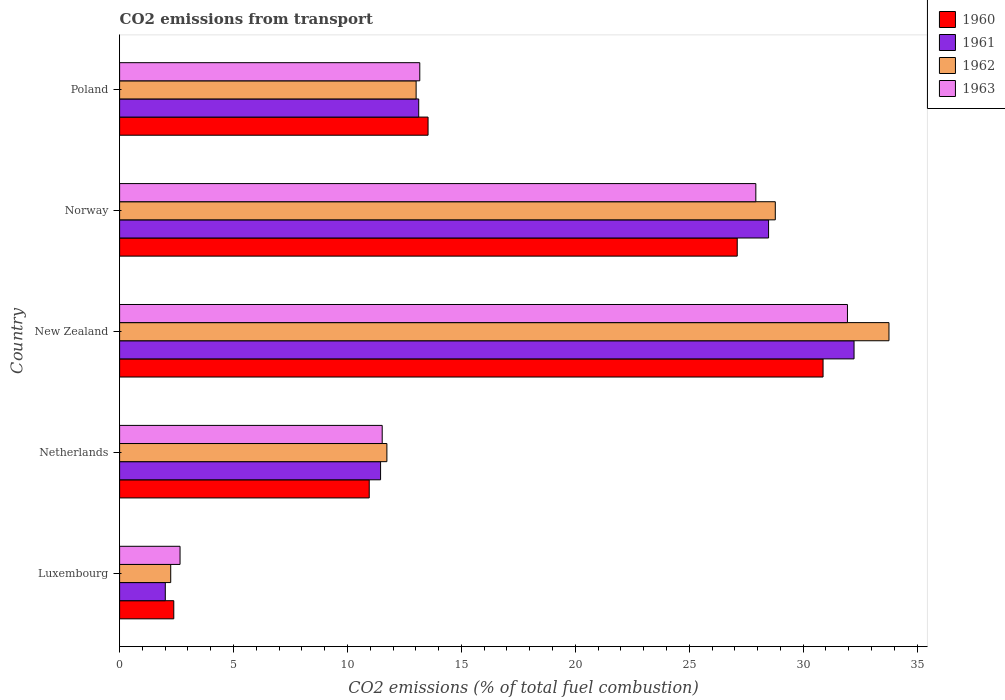How many different coloured bars are there?
Keep it short and to the point. 4. Are the number of bars on each tick of the Y-axis equal?
Your answer should be compact. Yes. What is the total CO2 emitted in 1963 in Luxembourg?
Your response must be concise. 2.65. Across all countries, what is the maximum total CO2 emitted in 1963?
Provide a succinct answer. 31.94. Across all countries, what is the minimum total CO2 emitted in 1960?
Your answer should be compact. 2.38. In which country was the total CO2 emitted in 1960 maximum?
Give a very brief answer. New Zealand. In which country was the total CO2 emitted in 1961 minimum?
Offer a terse response. Luxembourg. What is the total total CO2 emitted in 1963 in the graph?
Keep it short and to the point. 87.22. What is the difference between the total CO2 emitted in 1963 in Luxembourg and that in Norway?
Provide a succinct answer. -25.27. What is the difference between the total CO2 emitted in 1961 in Netherlands and the total CO2 emitted in 1963 in New Zealand?
Give a very brief answer. -20.49. What is the average total CO2 emitted in 1961 per country?
Keep it short and to the point. 17.46. What is the difference between the total CO2 emitted in 1960 and total CO2 emitted in 1963 in New Zealand?
Your answer should be compact. -1.07. In how many countries, is the total CO2 emitted in 1960 greater than 11 ?
Your answer should be compact. 3. What is the ratio of the total CO2 emitted in 1962 in Luxembourg to that in Norway?
Keep it short and to the point. 0.08. Is the difference between the total CO2 emitted in 1960 in New Zealand and Poland greater than the difference between the total CO2 emitted in 1963 in New Zealand and Poland?
Give a very brief answer. No. What is the difference between the highest and the second highest total CO2 emitted in 1962?
Ensure brevity in your answer.  4.99. What is the difference between the highest and the lowest total CO2 emitted in 1963?
Make the answer very short. 29.29. Is it the case that in every country, the sum of the total CO2 emitted in 1960 and total CO2 emitted in 1962 is greater than the sum of total CO2 emitted in 1961 and total CO2 emitted in 1963?
Your response must be concise. No. What is the difference between two consecutive major ticks on the X-axis?
Give a very brief answer. 5. Are the values on the major ticks of X-axis written in scientific E-notation?
Your answer should be very brief. No. Does the graph contain any zero values?
Your answer should be compact. No. Does the graph contain grids?
Provide a short and direct response. No. How many legend labels are there?
Your answer should be very brief. 4. What is the title of the graph?
Offer a terse response. CO2 emissions from transport. Does "1999" appear as one of the legend labels in the graph?
Make the answer very short. No. What is the label or title of the X-axis?
Provide a succinct answer. CO2 emissions (% of total fuel combustion). What is the label or title of the Y-axis?
Provide a short and direct response. Country. What is the CO2 emissions (% of total fuel combustion) in 1960 in Luxembourg?
Offer a very short reply. 2.38. What is the CO2 emissions (% of total fuel combustion) in 1961 in Luxembourg?
Give a very brief answer. 2.01. What is the CO2 emissions (% of total fuel combustion) of 1962 in Luxembourg?
Provide a short and direct response. 2.24. What is the CO2 emissions (% of total fuel combustion) in 1963 in Luxembourg?
Your answer should be compact. 2.65. What is the CO2 emissions (% of total fuel combustion) of 1960 in Netherlands?
Provide a short and direct response. 10.96. What is the CO2 emissions (% of total fuel combustion) of 1961 in Netherlands?
Your answer should be very brief. 11.45. What is the CO2 emissions (% of total fuel combustion) of 1962 in Netherlands?
Your response must be concise. 11.73. What is the CO2 emissions (% of total fuel combustion) in 1963 in Netherlands?
Give a very brief answer. 11.53. What is the CO2 emissions (% of total fuel combustion) of 1960 in New Zealand?
Your answer should be very brief. 30.87. What is the CO2 emissions (% of total fuel combustion) in 1961 in New Zealand?
Your answer should be compact. 32.23. What is the CO2 emissions (% of total fuel combustion) of 1962 in New Zealand?
Keep it short and to the point. 33.77. What is the CO2 emissions (% of total fuel combustion) in 1963 in New Zealand?
Provide a succinct answer. 31.94. What is the CO2 emissions (% of total fuel combustion) of 1960 in Norway?
Your answer should be compact. 27.11. What is the CO2 emissions (% of total fuel combustion) in 1961 in Norway?
Your response must be concise. 28.48. What is the CO2 emissions (% of total fuel combustion) in 1962 in Norway?
Provide a succinct answer. 28.78. What is the CO2 emissions (% of total fuel combustion) in 1963 in Norway?
Your answer should be compact. 27.92. What is the CO2 emissions (% of total fuel combustion) of 1960 in Poland?
Offer a terse response. 13.54. What is the CO2 emissions (% of total fuel combustion) in 1961 in Poland?
Give a very brief answer. 13.13. What is the CO2 emissions (% of total fuel combustion) of 1962 in Poland?
Provide a succinct answer. 13.01. What is the CO2 emissions (% of total fuel combustion) of 1963 in Poland?
Ensure brevity in your answer.  13.17. Across all countries, what is the maximum CO2 emissions (% of total fuel combustion) of 1960?
Make the answer very short. 30.87. Across all countries, what is the maximum CO2 emissions (% of total fuel combustion) of 1961?
Offer a very short reply. 32.23. Across all countries, what is the maximum CO2 emissions (% of total fuel combustion) in 1962?
Keep it short and to the point. 33.77. Across all countries, what is the maximum CO2 emissions (% of total fuel combustion) of 1963?
Make the answer very short. 31.94. Across all countries, what is the minimum CO2 emissions (% of total fuel combustion) of 1960?
Provide a short and direct response. 2.38. Across all countries, what is the minimum CO2 emissions (% of total fuel combustion) of 1961?
Your answer should be compact. 2.01. Across all countries, what is the minimum CO2 emissions (% of total fuel combustion) of 1962?
Provide a short and direct response. 2.24. Across all countries, what is the minimum CO2 emissions (% of total fuel combustion) in 1963?
Offer a terse response. 2.65. What is the total CO2 emissions (% of total fuel combustion) of 1960 in the graph?
Your response must be concise. 84.85. What is the total CO2 emissions (% of total fuel combustion) of 1961 in the graph?
Provide a short and direct response. 87.3. What is the total CO2 emissions (% of total fuel combustion) in 1962 in the graph?
Ensure brevity in your answer.  89.53. What is the total CO2 emissions (% of total fuel combustion) in 1963 in the graph?
Provide a succinct answer. 87.22. What is the difference between the CO2 emissions (% of total fuel combustion) in 1960 in Luxembourg and that in Netherlands?
Make the answer very short. -8.58. What is the difference between the CO2 emissions (% of total fuel combustion) of 1961 in Luxembourg and that in Netherlands?
Your answer should be very brief. -9.45. What is the difference between the CO2 emissions (% of total fuel combustion) of 1962 in Luxembourg and that in Netherlands?
Keep it short and to the point. -9.49. What is the difference between the CO2 emissions (% of total fuel combustion) of 1963 in Luxembourg and that in Netherlands?
Your answer should be compact. -8.87. What is the difference between the CO2 emissions (% of total fuel combustion) in 1960 in Luxembourg and that in New Zealand?
Ensure brevity in your answer.  -28.5. What is the difference between the CO2 emissions (% of total fuel combustion) of 1961 in Luxembourg and that in New Zealand?
Give a very brief answer. -30.23. What is the difference between the CO2 emissions (% of total fuel combustion) in 1962 in Luxembourg and that in New Zealand?
Your response must be concise. -31.52. What is the difference between the CO2 emissions (% of total fuel combustion) of 1963 in Luxembourg and that in New Zealand?
Give a very brief answer. -29.29. What is the difference between the CO2 emissions (% of total fuel combustion) of 1960 in Luxembourg and that in Norway?
Provide a short and direct response. -24.73. What is the difference between the CO2 emissions (% of total fuel combustion) of 1961 in Luxembourg and that in Norway?
Make the answer very short. -26.48. What is the difference between the CO2 emissions (% of total fuel combustion) in 1962 in Luxembourg and that in Norway?
Your answer should be very brief. -26.53. What is the difference between the CO2 emissions (% of total fuel combustion) in 1963 in Luxembourg and that in Norway?
Your response must be concise. -25.27. What is the difference between the CO2 emissions (% of total fuel combustion) of 1960 in Luxembourg and that in Poland?
Make the answer very short. -11.16. What is the difference between the CO2 emissions (% of total fuel combustion) of 1961 in Luxembourg and that in Poland?
Offer a very short reply. -11.12. What is the difference between the CO2 emissions (% of total fuel combustion) of 1962 in Luxembourg and that in Poland?
Your answer should be very brief. -10.77. What is the difference between the CO2 emissions (% of total fuel combustion) of 1963 in Luxembourg and that in Poland?
Your answer should be very brief. -10.52. What is the difference between the CO2 emissions (% of total fuel combustion) of 1960 in Netherlands and that in New Zealand?
Provide a succinct answer. -19.92. What is the difference between the CO2 emissions (% of total fuel combustion) of 1961 in Netherlands and that in New Zealand?
Your answer should be compact. -20.78. What is the difference between the CO2 emissions (% of total fuel combustion) of 1962 in Netherlands and that in New Zealand?
Provide a succinct answer. -22.04. What is the difference between the CO2 emissions (% of total fuel combustion) of 1963 in Netherlands and that in New Zealand?
Keep it short and to the point. -20.42. What is the difference between the CO2 emissions (% of total fuel combustion) in 1960 in Netherlands and that in Norway?
Provide a short and direct response. -16.15. What is the difference between the CO2 emissions (% of total fuel combustion) in 1961 in Netherlands and that in Norway?
Keep it short and to the point. -17.03. What is the difference between the CO2 emissions (% of total fuel combustion) in 1962 in Netherlands and that in Norway?
Your answer should be compact. -17.05. What is the difference between the CO2 emissions (% of total fuel combustion) in 1963 in Netherlands and that in Norway?
Keep it short and to the point. -16.4. What is the difference between the CO2 emissions (% of total fuel combustion) in 1960 in Netherlands and that in Poland?
Provide a succinct answer. -2.58. What is the difference between the CO2 emissions (% of total fuel combustion) in 1961 in Netherlands and that in Poland?
Keep it short and to the point. -1.67. What is the difference between the CO2 emissions (% of total fuel combustion) in 1962 in Netherlands and that in Poland?
Give a very brief answer. -1.28. What is the difference between the CO2 emissions (% of total fuel combustion) of 1963 in Netherlands and that in Poland?
Give a very brief answer. -1.65. What is the difference between the CO2 emissions (% of total fuel combustion) in 1960 in New Zealand and that in Norway?
Make the answer very short. 3.77. What is the difference between the CO2 emissions (% of total fuel combustion) in 1961 in New Zealand and that in Norway?
Keep it short and to the point. 3.75. What is the difference between the CO2 emissions (% of total fuel combustion) of 1962 in New Zealand and that in Norway?
Keep it short and to the point. 4.99. What is the difference between the CO2 emissions (% of total fuel combustion) in 1963 in New Zealand and that in Norway?
Offer a very short reply. 4.02. What is the difference between the CO2 emissions (% of total fuel combustion) in 1960 in New Zealand and that in Poland?
Provide a short and direct response. 17.34. What is the difference between the CO2 emissions (% of total fuel combustion) in 1961 in New Zealand and that in Poland?
Provide a short and direct response. 19.11. What is the difference between the CO2 emissions (% of total fuel combustion) of 1962 in New Zealand and that in Poland?
Your answer should be compact. 20.75. What is the difference between the CO2 emissions (% of total fuel combustion) of 1963 in New Zealand and that in Poland?
Offer a very short reply. 18.77. What is the difference between the CO2 emissions (% of total fuel combustion) of 1960 in Norway and that in Poland?
Ensure brevity in your answer.  13.57. What is the difference between the CO2 emissions (% of total fuel combustion) in 1961 in Norway and that in Poland?
Offer a terse response. 15.36. What is the difference between the CO2 emissions (% of total fuel combustion) in 1962 in Norway and that in Poland?
Offer a terse response. 15.76. What is the difference between the CO2 emissions (% of total fuel combustion) in 1963 in Norway and that in Poland?
Provide a succinct answer. 14.75. What is the difference between the CO2 emissions (% of total fuel combustion) in 1960 in Luxembourg and the CO2 emissions (% of total fuel combustion) in 1961 in Netherlands?
Offer a terse response. -9.08. What is the difference between the CO2 emissions (% of total fuel combustion) in 1960 in Luxembourg and the CO2 emissions (% of total fuel combustion) in 1962 in Netherlands?
Give a very brief answer. -9.35. What is the difference between the CO2 emissions (% of total fuel combustion) in 1960 in Luxembourg and the CO2 emissions (% of total fuel combustion) in 1963 in Netherlands?
Provide a succinct answer. -9.15. What is the difference between the CO2 emissions (% of total fuel combustion) of 1961 in Luxembourg and the CO2 emissions (% of total fuel combustion) of 1962 in Netherlands?
Ensure brevity in your answer.  -9.72. What is the difference between the CO2 emissions (% of total fuel combustion) of 1961 in Luxembourg and the CO2 emissions (% of total fuel combustion) of 1963 in Netherlands?
Your answer should be very brief. -9.52. What is the difference between the CO2 emissions (% of total fuel combustion) of 1962 in Luxembourg and the CO2 emissions (% of total fuel combustion) of 1963 in Netherlands?
Provide a short and direct response. -9.28. What is the difference between the CO2 emissions (% of total fuel combustion) in 1960 in Luxembourg and the CO2 emissions (% of total fuel combustion) in 1961 in New Zealand?
Offer a terse response. -29.86. What is the difference between the CO2 emissions (% of total fuel combustion) of 1960 in Luxembourg and the CO2 emissions (% of total fuel combustion) of 1962 in New Zealand?
Provide a succinct answer. -31.39. What is the difference between the CO2 emissions (% of total fuel combustion) of 1960 in Luxembourg and the CO2 emissions (% of total fuel combustion) of 1963 in New Zealand?
Make the answer very short. -29.57. What is the difference between the CO2 emissions (% of total fuel combustion) of 1961 in Luxembourg and the CO2 emissions (% of total fuel combustion) of 1962 in New Zealand?
Offer a terse response. -31.76. What is the difference between the CO2 emissions (% of total fuel combustion) in 1961 in Luxembourg and the CO2 emissions (% of total fuel combustion) in 1963 in New Zealand?
Your answer should be compact. -29.94. What is the difference between the CO2 emissions (% of total fuel combustion) of 1962 in Luxembourg and the CO2 emissions (% of total fuel combustion) of 1963 in New Zealand?
Your response must be concise. -29.7. What is the difference between the CO2 emissions (% of total fuel combustion) of 1960 in Luxembourg and the CO2 emissions (% of total fuel combustion) of 1961 in Norway?
Keep it short and to the point. -26.1. What is the difference between the CO2 emissions (% of total fuel combustion) of 1960 in Luxembourg and the CO2 emissions (% of total fuel combustion) of 1962 in Norway?
Your answer should be compact. -26.4. What is the difference between the CO2 emissions (% of total fuel combustion) in 1960 in Luxembourg and the CO2 emissions (% of total fuel combustion) in 1963 in Norway?
Offer a terse response. -25.54. What is the difference between the CO2 emissions (% of total fuel combustion) in 1961 in Luxembourg and the CO2 emissions (% of total fuel combustion) in 1962 in Norway?
Your answer should be compact. -26.77. What is the difference between the CO2 emissions (% of total fuel combustion) in 1961 in Luxembourg and the CO2 emissions (% of total fuel combustion) in 1963 in Norway?
Make the answer very short. -25.92. What is the difference between the CO2 emissions (% of total fuel combustion) in 1962 in Luxembourg and the CO2 emissions (% of total fuel combustion) in 1963 in Norway?
Provide a short and direct response. -25.68. What is the difference between the CO2 emissions (% of total fuel combustion) in 1960 in Luxembourg and the CO2 emissions (% of total fuel combustion) in 1961 in Poland?
Ensure brevity in your answer.  -10.75. What is the difference between the CO2 emissions (% of total fuel combustion) in 1960 in Luxembourg and the CO2 emissions (% of total fuel combustion) in 1962 in Poland?
Offer a very short reply. -10.64. What is the difference between the CO2 emissions (% of total fuel combustion) in 1960 in Luxembourg and the CO2 emissions (% of total fuel combustion) in 1963 in Poland?
Provide a short and direct response. -10.8. What is the difference between the CO2 emissions (% of total fuel combustion) of 1961 in Luxembourg and the CO2 emissions (% of total fuel combustion) of 1962 in Poland?
Your answer should be compact. -11.01. What is the difference between the CO2 emissions (% of total fuel combustion) of 1961 in Luxembourg and the CO2 emissions (% of total fuel combustion) of 1963 in Poland?
Make the answer very short. -11.17. What is the difference between the CO2 emissions (% of total fuel combustion) of 1962 in Luxembourg and the CO2 emissions (% of total fuel combustion) of 1963 in Poland?
Make the answer very short. -10.93. What is the difference between the CO2 emissions (% of total fuel combustion) of 1960 in Netherlands and the CO2 emissions (% of total fuel combustion) of 1961 in New Zealand?
Keep it short and to the point. -21.28. What is the difference between the CO2 emissions (% of total fuel combustion) of 1960 in Netherlands and the CO2 emissions (% of total fuel combustion) of 1962 in New Zealand?
Offer a terse response. -22.81. What is the difference between the CO2 emissions (% of total fuel combustion) in 1960 in Netherlands and the CO2 emissions (% of total fuel combustion) in 1963 in New Zealand?
Keep it short and to the point. -20.99. What is the difference between the CO2 emissions (% of total fuel combustion) in 1961 in Netherlands and the CO2 emissions (% of total fuel combustion) in 1962 in New Zealand?
Ensure brevity in your answer.  -22.31. What is the difference between the CO2 emissions (% of total fuel combustion) in 1961 in Netherlands and the CO2 emissions (% of total fuel combustion) in 1963 in New Zealand?
Your response must be concise. -20.49. What is the difference between the CO2 emissions (% of total fuel combustion) in 1962 in Netherlands and the CO2 emissions (% of total fuel combustion) in 1963 in New Zealand?
Your answer should be compact. -20.21. What is the difference between the CO2 emissions (% of total fuel combustion) in 1960 in Netherlands and the CO2 emissions (% of total fuel combustion) in 1961 in Norway?
Your answer should be very brief. -17.53. What is the difference between the CO2 emissions (% of total fuel combustion) of 1960 in Netherlands and the CO2 emissions (% of total fuel combustion) of 1962 in Norway?
Your answer should be compact. -17.82. What is the difference between the CO2 emissions (% of total fuel combustion) in 1960 in Netherlands and the CO2 emissions (% of total fuel combustion) in 1963 in Norway?
Provide a short and direct response. -16.97. What is the difference between the CO2 emissions (% of total fuel combustion) in 1961 in Netherlands and the CO2 emissions (% of total fuel combustion) in 1962 in Norway?
Provide a short and direct response. -17.32. What is the difference between the CO2 emissions (% of total fuel combustion) in 1961 in Netherlands and the CO2 emissions (% of total fuel combustion) in 1963 in Norway?
Your answer should be very brief. -16.47. What is the difference between the CO2 emissions (% of total fuel combustion) of 1962 in Netherlands and the CO2 emissions (% of total fuel combustion) of 1963 in Norway?
Offer a terse response. -16.19. What is the difference between the CO2 emissions (% of total fuel combustion) of 1960 in Netherlands and the CO2 emissions (% of total fuel combustion) of 1961 in Poland?
Provide a short and direct response. -2.17. What is the difference between the CO2 emissions (% of total fuel combustion) in 1960 in Netherlands and the CO2 emissions (% of total fuel combustion) in 1962 in Poland?
Provide a short and direct response. -2.06. What is the difference between the CO2 emissions (% of total fuel combustion) in 1960 in Netherlands and the CO2 emissions (% of total fuel combustion) in 1963 in Poland?
Offer a very short reply. -2.22. What is the difference between the CO2 emissions (% of total fuel combustion) of 1961 in Netherlands and the CO2 emissions (% of total fuel combustion) of 1962 in Poland?
Provide a short and direct response. -1.56. What is the difference between the CO2 emissions (% of total fuel combustion) in 1961 in Netherlands and the CO2 emissions (% of total fuel combustion) in 1963 in Poland?
Offer a very short reply. -1.72. What is the difference between the CO2 emissions (% of total fuel combustion) of 1962 in Netherlands and the CO2 emissions (% of total fuel combustion) of 1963 in Poland?
Offer a very short reply. -1.44. What is the difference between the CO2 emissions (% of total fuel combustion) in 1960 in New Zealand and the CO2 emissions (% of total fuel combustion) in 1961 in Norway?
Offer a very short reply. 2.39. What is the difference between the CO2 emissions (% of total fuel combustion) in 1960 in New Zealand and the CO2 emissions (% of total fuel combustion) in 1962 in Norway?
Your answer should be compact. 2.1. What is the difference between the CO2 emissions (% of total fuel combustion) of 1960 in New Zealand and the CO2 emissions (% of total fuel combustion) of 1963 in Norway?
Your response must be concise. 2.95. What is the difference between the CO2 emissions (% of total fuel combustion) in 1961 in New Zealand and the CO2 emissions (% of total fuel combustion) in 1962 in Norway?
Your response must be concise. 3.46. What is the difference between the CO2 emissions (% of total fuel combustion) of 1961 in New Zealand and the CO2 emissions (% of total fuel combustion) of 1963 in Norway?
Your answer should be compact. 4.31. What is the difference between the CO2 emissions (% of total fuel combustion) of 1962 in New Zealand and the CO2 emissions (% of total fuel combustion) of 1963 in Norway?
Your response must be concise. 5.84. What is the difference between the CO2 emissions (% of total fuel combustion) of 1960 in New Zealand and the CO2 emissions (% of total fuel combustion) of 1961 in Poland?
Your answer should be compact. 17.75. What is the difference between the CO2 emissions (% of total fuel combustion) in 1960 in New Zealand and the CO2 emissions (% of total fuel combustion) in 1962 in Poland?
Your answer should be very brief. 17.86. What is the difference between the CO2 emissions (% of total fuel combustion) of 1960 in New Zealand and the CO2 emissions (% of total fuel combustion) of 1963 in Poland?
Make the answer very short. 17.7. What is the difference between the CO2 emissions (% of total fuel combustion) in 1961 in New Zealand and the CO2 emissions (% of total fuel combustion) in 1962 in Poland?
Your response must be concise. 19.22. What is the difference between the CO2 emissions (% of total fuel combustion) in 1961 in New Zealand and the CO2 emissions (% of total fuel combustion) in 1963 in Poland?
Offer a very short reply. 19.06. What is the difference between the CO2 emissions (% of total fuel combustion) of 1962 in New Zealand and the CO2 emissions (% of total fuel combustion) of 1963 in Poland?
Keep it short and to the point. 20.59. What is the difference between the CO2 emissions (% of total fuel combustion) in 1960 in Norway and the CO2 emissions (% of total fuel combustion) in 1961 in Poland?
Ensure brevity in your answer.  13.98. What is the difference between the CO2 emissions (% of total fuel combustion) of 1960 in Norway and the CO2 emissions (% of total fuel combustion) of 1962 in Poland?
Give a very brief answer. 14.09. What is the difference between the CO2 emissions (% of total fuel combustion) of 1960 in Norway and the CO2 emissions (% of total fuel combustion) of 1963 in Poland?
Give a very brief answer. 13.93. What is the difference between the CO2 emissions (% of total fuel combustion) of 1961 in Norway and the CO2 emissions (% of total fuel combustion) of 1962 in Poland?
Make the answer very short. 15.47. What is the difference between the CO2 emissions (% of total fuel combustion) of 1961 in Norway and the CO2 emissions (% of total fuel combustion) of 1963 in Poland?
Make the answer very short. 15.31. What is the difference between the CO2 emissions (% of total fuel combustion) in 1962 in Norway and the CO2 emissions (% of total fuel combustion) in 1963 in Poland?
Ensure brevity in your answer.  15.6. What is the average CO2 emissions (% of total fuel combustion) of 1960 per country?
Ensure brevity in your answer.  16.97. What is the average CO2 emissions (% of total fuel combustion) in 1961 per country?
Offer a very short reply. 17.46. What is the average CO2 emissions (% of total fuel combustion) in 1962 per country?
Provide a short and direct response. 17.91. What is the average CO2 emissions (% of total fuel combustion) of 1963 per country?
Your answer should be very brief. 17.44. What is the difference between the CO2 emissions (% of total fuel combustion) in 1960 and CO2 emissions (% of total fuel combustion) in 1961 in Luxembourg?
Your response must be concise. 0.37. What is the difference between the CO2 emissions (% of total fuel combustion) of 1960 and CO2 emissions (% of total fuel combustion) of 1962 in Luxembourg?
Offer a very short reply. 0.14. What is the difference between the CO2 emissions (% of total fuel combustion) of 1960 and CO2 emissions (% of total fuel combustion) of 1963 in Luxembourg?
Make the answer very short. -0.27. What is the difference between the CO2 emissions (% of total fuel combustion) of 1961 and CO2 emissions (% of total fuel combustion) of 1962 in Luxembourg?
Your response must be concise. -0.24. What is the difference between the CO2 emissions (% of total fuel combustion) in 1961 and CO2 emissions (% of total fuel combustion) in 1963 in Luxembourg?
Offer a very short reply. -0.65. What is the difference between the CO2 emissions (% of total fuel combustion) of 1962 and CO2 emissions (% of total fuel combustion) of 1963 in Luxembourg?
Provide a succinct answer. -0.41. What is the difference between the CO2 emissions (% of total fuel combustion) in 1960 and CO2 emissions (% of total fuel combustion) in 1961 in Netherlands?
Give a very brief answer. -0.5. What is the difference between the CO2 emissions (% of total fuel combustion) of 1960 and CO2 emissions (% of total fuel combustion) of 1962 in Netherlands?
Provide a short and direct response. -0.77. What is the difference between the CO2 emissions (% of total fuel combustion) of 1960 and CO2 emissions (% of total fuel combustion) of 1963 in Netherlands?
Provide a succinct answer. -0.57. What is the difference between the CO2 emissions (% of total fuel combustion) of 1961 and CO2 emissions (% of total fuel combustion) of 1962 in Netherlands?
Keep it short and to the point. -0.28. What is the difference between the CO2 emissions (% of total fuel combustion) of 1961 and CO2 emissions (% of total fuel combustion) of 1963 in Netherlands?
Make the answer very short. -0.07. What is the difference between the CO2 emissions (% of total fuel combustion) of 1962 and CO2 emissions (% of total fuel combustion) of 1963 in Netherlands?
Provide a short and direct response. 0.21. What is the difference between the CO2 emissions (% of total fuel combustion) in 1960 and CO2 emissions (% of total fuel combustion) in 1961 in New Zealand?
Give a very brief answer. -1.36. What is the difference between the CO2 emissions (% of total fuel combustion) of 1960 and CO2 emissions (% of total fuel combustion) of 1962 in New Zealand?
Ensure brevity in your answer.  -2.89. What is the difference between the CO2 emissions (% of total fuel combustion) in 1960 and CO2 emissions (% of total fuel combustion) in 1963 in New Zealand?
Keep it short and to the point. -1.07. What is the difference between the CO2 emissions (% of total fuel combustion) of 1961 and CO2 emissions (% of total fuel combustion) of 1962 in New Zealand?
Your response must be concise. -1.53. What is the difference between the CO2 emissions (% of total fuel combustion) in 1961 and CO2 emissions (% of total fuel combustion) in 1963 in New Zealand?
Provide a succinct answer. 0.29. What is the difference between the CO2 emissions (% of total fuel combustion) in 1962 and CO2 emissions (% of total fuel combustion) in 1963 in New Zealand?
Give a very brief answer. 1.82. What is the difference between the CO2 emissions (% of total fuel combustion) of 1960 and CO2 emissions (% of total fuel combustion) of 1961 in Norway?
Offer a very short reply. -1.38. What is the difference between the CO2 emissions (% of total fuel combustion) of 1960 and CO2 emissions (% of total fuel combustion) of 1962 in Norway?
Ensure brevity in your answer.  -1.67. What is the difference between the CO2 emissions (% of total fuel combustion) of 1960 and CO2 emissions (% of total fuel combustion) of 1963 in Norway?
Ensure brevity in your answer.  -0.82. What is the difference between the CO2 emissions (% of total fuel combustion) of 1961 and CO2 emissions (% of total fuel combustion) of 1962 in Norway?
Your answer should be very brief. -0.29. What is the difference between the CO2 emissions (% of total fuel combustion) of 1961 and CO2 emissions (% of total fuel combustion) of 1963 in Norway?
Your response must be concise. 0.56. What is the difference between the CO2 emissions (% of total fuel combustion) of 1962 and CO2 emissions (% of total fuel combustion) of 1963 in Norway?
Offer a terse response. 0.85. What is the difference between the CO2 emissions (% of total fuel combustion) in 1960 and CO2 emissions (% of total fuel combustion) in 1961 in Poland?
Provide a short and direct response. 0.41. What is the difference between the CO2 emissions (% of total fuel combustion) of 1960 and CO2 emissions (% of total fuel combustion) of 1962 in Poland?
Ensure brevity in your answer.  0.52. What is the difference between the CO2 emissions (% of total fuel combustion) in 1960 and CO2 emissions (% of total fuel combustion) in 1963 in Poland?
Your response must be concise. 0.36. What is the difference between the CO2 emissions (% of total fuel combustion) of 1961 and CO2 emissions (% of total fuel combustion) of 1962 in Poland?
Your answer should be very brief. 0.11. What is the difference between the CO2 emissions (% of total fuel combustion) of 1961 and CO2 emissions (% of total fuel combustion) of 1963 in Poland?
Give a very brief answer. -0.05. What is the difference between the CO2 emissions (% of total fuel combustion) of 1962 and CO2 emissions (% of total fuel combustion) of 1963 in Poland?
Give a very brief answer. -0.16. What is the ratio of the CO2 emissions (% of total fuel combustion) of 1960 in Luxembourg to that in Netherlands?
Give a very brief answer. 0.22. What is the ratio of the CO2 emissions (% of total fuel combustion) of 1961 in Luxembourg to that in Netherlands?
Offer a terse response. 0.18. What is the ratio of the CO2 emissions (% of total fuel combustion) in 1962 in Luxembourg to that in Netherlands?
Your response must be concise. 0.19. What is the ratio of the CO2 emissions (% of total fuel combustion) in 1963 in Luxembourg to that in Netherlands?
Provide a short and direct response. 0.23. What is the ratio of the CO2 emissions (% of total fuel combustion) in 1960 in Luxembourg to that in New Zealand?
Make the answer very short. 0.08. What is the ratio of the CO2 emissions (% of total fuel combustion) in 1961 in Luxembourg to that in New Zealand?
Your answer should be very brief. 0.06. What is the ratio of the CO2 emissions (% of total fuel combustion) in 1962 in Luxembourg to that in New Zealand?
Give a very brief answer. 0.07. What is the ratio of the CO2 emissions (% of total fuel combustion) in 1963 in Luxembourg to that in New Zealand?
Offer a very short reply. 0.08. What is the ratio of the CO2 emissions (% of total fuel combustion) in 1960 in Luxembourg to that in Norway?
Offer a very short reply. 0.09. What is the ratio of the CO2 emissions (% of total fuel combustion) in 1961 in Luxembourg to that in Norway?
Ensure brevity in your answer.  0.07. What is the ratio of the CO2 emissions (% of total fuel combustion) in 1962 in Luxembourg to that in Norway?
Provide a succinct answer. 0.08. What is the ratio of the CO2 emissions (% of total fuel combustion) in 1963 in Luxembourg to that in Norway?
Your answer should be compact. 0.1. What is the ratio of the CO2 emissions (% of total fuel combustion) of 1960 in Luxembourg to that in Poland?
Your answer should be compact. 0.18. What is the ratio of the CO2 emissions (% of total fuel combustion) in 1961 in Luxembourg to that in Poland?
Your answer should be compact. 0.15. What is the ratio of the CO2 emissions (% of total fuel combustion) in 1962 in Luxembourg to that in Poland?
Ensure brevity in your answer.  0.17. What is the ratio of the CO2 emissions (% of total fuel combustion) in 1963 in Luxembourg to that in Poland?
Provide a succinct answer. 0.2. What is the ratio of the CO2 emissions (% of total fuel combustion) in 1960 in Netherlands to that in New Zealand?
Your response must be concise. 0.35. What is the ratio of the CO2 emissions (% of total fuel combustion) in 1961 in Netherlands to that in New Zealand?
Your response must be concise. 0.36. What is the ratio of the CO2 emissions (% of total fuel combustion) in 1962 in Netherlands to that in New Zealand?
Ensure brevity in your answer.  0.35. What is the ratio of the CO2 emissions (% of total fuel combustion) of 1963 in Netherlands to that in New Zealand?
Provide a short and direct response. 0.36. What is the ratio of the CO2 emissions (% of total fuel combustion) of 1960 in Netherlands to that in Norway?
Provide a succinct answer. 0.4. What is the ratio of the CO2 emissions (% of total fuel combustion) of 1961 in Netherlands to that in Norway?
Your response must be concise. 0.4. What is the ratio of the CO2 emissions (% of total fuel combustion) in 1962 in Netherlands to that in Norway?
Ensure brevity in your answer.  0.41. What is the ratio of the CO2 emissions (% of total fuel combustion) of 1963 in Netherlands to that in Norway?
Offer a very short reply. 0.41. What is the ratio of the CO2 emissions (% of total fuel combustion) in 1960 in Netherlands to that in Poland?
Your response must be concise. 0.81. What is the ratio of the CO2 emissions (% of total fuel combustion) in 1961 in Netherlands to that in Poland?
Keep it short and to the point. 0.87. What is the ratio of the CO2 emissions (% of total fuel combustion) of 1962 in Netherlands to that in Poland?
Ensure brevity in your answer.  0.9. What is the ratio of the CO2 emissions (% of total fuel combustion) in 1963 in Netherlands to that in Poland?
Ensure brevity in your answer.  0.87. What is the ratio of the CO2 emissions (% of total fuel combustion) in 1960 in New Zealand to that in Norway?
Give a very brief answer. 1.14. What is the ratio of the CO2 emissions (% of total fuel combustion) in 1961 in New Zealand to that in Norway?
Your response must be concise. 1.13. What is the ratio of the CO2 emissions (% of total fuel combustion) of 1962 in New Zealand to that in Norway?
Ensure brevity in your answer.  1.17. What is the ratio of the CO2 emissions (% of total fuel combustion) in 1963 in New Zealand to that in Norway?
Provide a succinct answer. 1.14. What is the ratio of the CO2 emissions (% of total fuel combustion) of 1960 in New Zealand to that in Poland?
Provide a short and direct response. 2.28. What is the ratio of the CO2 emissions (% of total fuel combustion) of 1961 in New Zealand to that in Poland?
Ensure brevity in your answer.  2.46. What is the ratio of the CO2 emissions (% of total fuel combustion) of 1962 in New Zealand to that in Poland?
Your answer should be compact. 2.59. What is the ratio of the CO2 emissions (% of total fuel combustion) of 1963 in New Zealand to that in Poland?
Give a very brief answer. 2.42. What is the ratio of the CO2 emissions (% of total fuel combustion) in 1960 in Norway to that in Poland?
Make the answer very short. 2. What is the ratio of the CO2 emissions (% of total fuel combustion) of 1961 in Norway to that in Poland?
Your answer should be very brief. 2.17. What is the ratio of the CO2 emissions (% of total fuel combustion) in 1962 in Norway to that in Poland?
Give a very brief answer. 2.21. What is the ratio of the CO2 emissions (% of total fuel combustion) of 1963 in Norway to that in Poland?
Give a very brief answer. 2.12. What is the difference between the highest and the second highest CO2 emissions (% of total fuel combustion) in 1960?
Provide a short and direct response. 3.77. What is the difference between the highest and the second highest CO2 emissions (% of total fuel combustion) in 1961?
Give a very brief answer. 3.75. What is the difference between the highest and the second highest CO2 emissions (% of total fuel combustion) of 1962?
Your answer should be compact. 4.99. What is the difference between the highest and the second highest CO2 emissions (% of total fuel combustion) in 1963?
Provide a succinct answer. 4.02. What is the difference between the highest and the lowest CO2 emissions (% of total fuel combustion) in 1960?
Keep it short and to the point. 28.5. What is the difference between the highest and the lowest CO2 emissions (% of total fuel combustion) in 1961?
Provide a succinct answer. 30.23. What is the difference between the highest and the lowest CO2 emissions (% of total fuel combustion) in 1962?
Your response must be concise. 31.52. What is the difference between the highest and the lowest CO2 emissions (% of total fuel combustion) in 1963?
Offer a terse response. 29.29. 